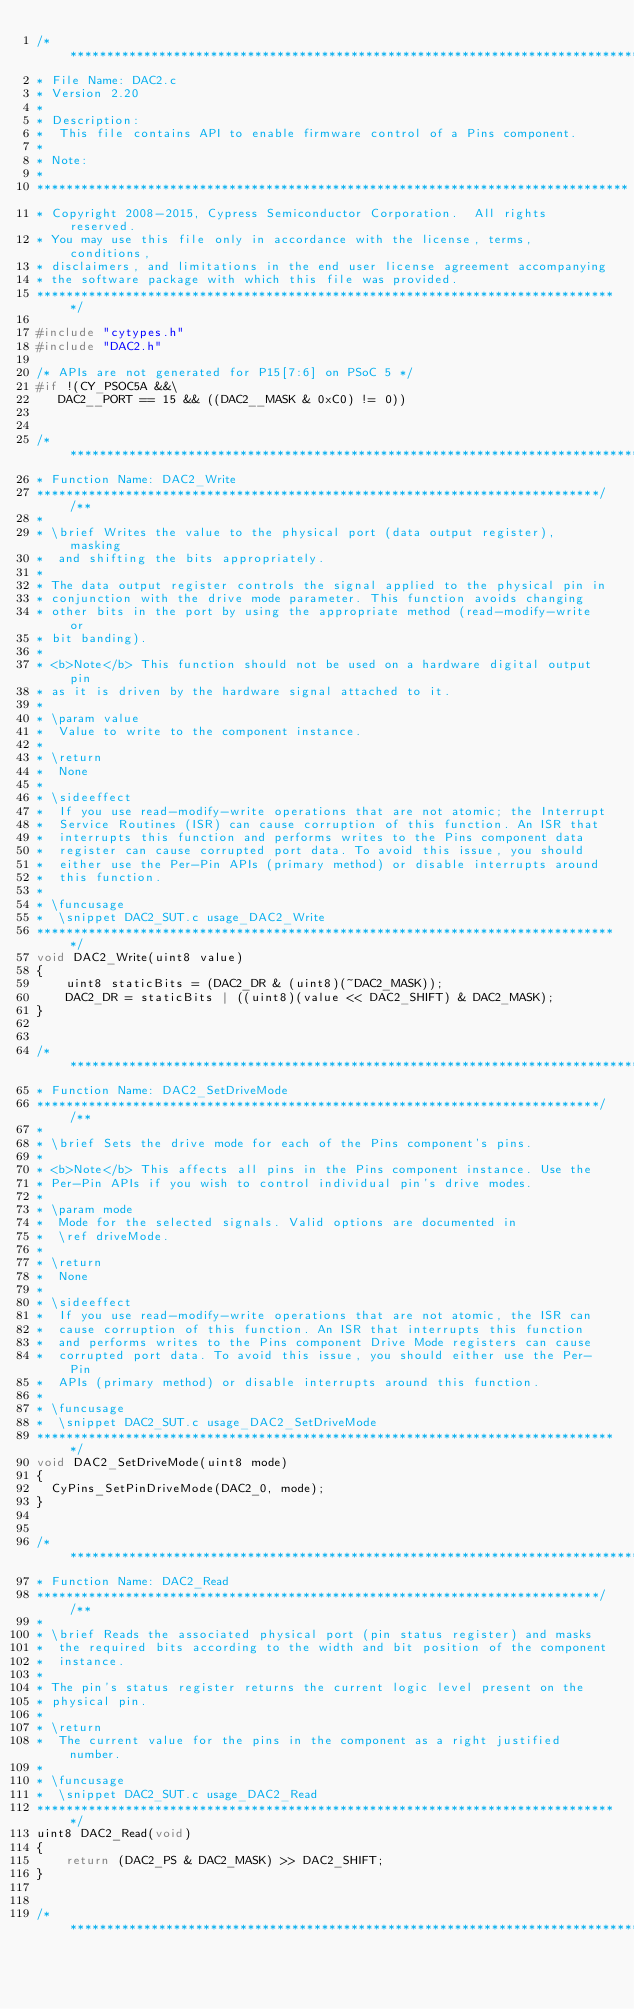<code> <loc_0><loc_0><loc_500><loc_500><_C_>/*******************************************************************************
* File Name: DAC2.c  
* Version 2.20
*
* Description:
*  This file contains API to enable firmware control of a Pins component.
*
* Note:
*
********************************************************************************
* Copyright 2008-2015, Cypress Semiconductor Corporation.  All rights reserved.
* You may use this file only in accordance with the license, terms, conditions, 
* disclaimers, and limitations in the end user license agreement accompanying 
* the software package with which this file was provided.
*******************************************************************************/

#include "cytypes.h"
#include "DAC2.h"

/* APIs are not generated for P15[7:6] on PSoC 5 */
#if !(CY_PSOC5A &&\
	 DAC2__PORT == 15 && ((DAC2__MASK & 0xC0) != 0))


/*******************************************************************************
* Function Name: DAC2_Write
****************************************************************************//**
*
* \brief Writes the value to the physical port (data output register), masking
*  and shifting the bits appropriately. 
*
* The data output register controls the signal applied to the physical pin in 
* conjunction with the drive mode parameter. This function avoids changing 
* other bits in the port by using the appropriate method (read-modify-write or
* bit banding).
*
* <b>Note</b> This function should not be used on a hardware digital output pin 
* as it is driven by the hardware signal attached to it.
*
* \param value
*  Value to write to the component instance.
*
* \return 
*  None 
*
* \sideeffect
*  If you use read-modify-write operations that are not atomic; the Interrupt 
*  Service Routines (ISR) can cause corruption of this function. An ISR that 
*  interrupts this function and performs writes to the Pins component data 
*  register can cause corrupted port data. To avoid this issue, you should 
*  either use the Per-Pin APIs (primary method) or disable interrupts around 
*  this function.
*
* \funcusage
*  \snippet DAC2_SUT.c usage_DAC2_Write
*******************************************************************************/
void DAC2_Write(uint8 value)
{
    uint8 staticBits = (DAC2_DR & (uint8)(~DAC2_MASK));
    DAC2_DR = staticBits | ((uint8)(value << DAC2_SHIFT) & DAC2_MASK);
}


/*******************************************************************************
* Function Name: DAC2_SetDriveMode
****************************************************************************//**
*
* \brief Sets the drive mode for each of the Pins component's pins.
* 
* <b>Note</b> This affects all pins in the Pins component instance. Use the
* Per-Pin APIs if you wish to control individual pin's drive modes.
*
* \param mode
*  Mode for the selected signals. Valid options are documented in 
*  \ref driveMode.
*
* \return
*  None
*
* \sideeffect
*  If you use read-modify-write operations that are not atomic, the ISR can
*  cause corruption of this function. An ISR that interrupts this function 
*  and performs writes to the Pins component Drive Mode registers can cause 
*  corrupted port data. To avoid this issue, you should either use the Per-Pin
*  APIs (primary method) or disable interrupts around this function.
*
* \funcusage
*  \snippet DAC2_SUT.c usage_DAC2_SetDriveMode
*******************************************************************************/
void DAC2_SetDriveMode(uint8 mode)
{
	CyPins_SetPinDriveMode(DAC2_0, mode);
}


/*******************************************************************************
* Function Name: DAC2_Read
****************************************************************************//**
*
* \brief Reads the associated physical port (pin status register) and masks 
*  the required bits according to the width and bit position of the component
*  instance. 
*
* The pin's status register returns the current logic level present on the 
* physical pin.
*
* \return 
*  The current value for the pins in the component as a right justified number.
*
* \funcusage
*  \snippet DAC2_SUT.c usage_DAC2_Read  
*******************************************************************************/
uint8 DAC2_Read(void)
{
    return (DAC2_PS & DAC2_MASK) >> DAC2_SHIFT;
}


/*******************************************************************************</code> 